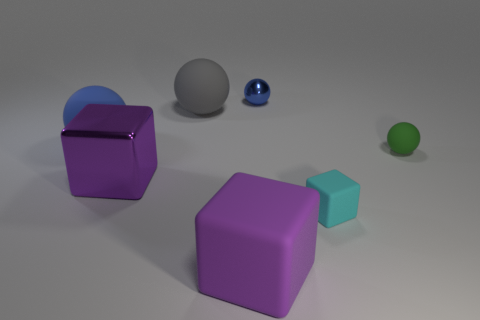Can you describe the textures of the objects shown? Certainly! The two purple cubes have a smooth matte finish, the larger blue ball appears to have a matte texture as well, whereas the smaller blue ball seems to have a shiny, reflective surface, and the small green ball looks like it has a metallic sheen. 